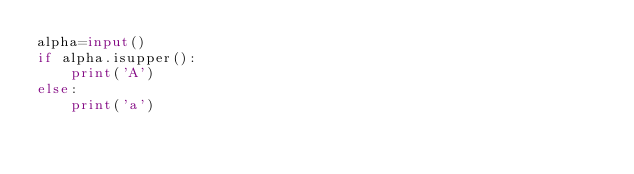Convert code to text. <code><loc_0><loc_0><loc_500><loc_500><_Python_>alpha=input()
if alpha.isupper():
    print('A')
else:
    print('a')
</code> 